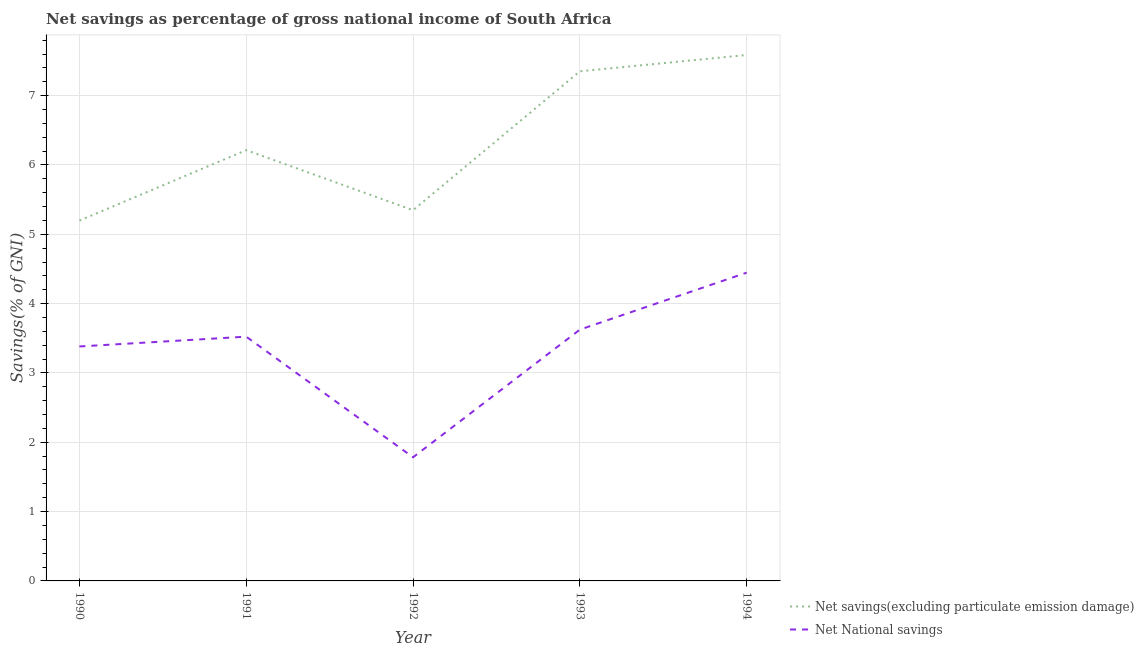Does the line corresponding to net savings(excluding particulate emission damage) intersect with the line corresponding to net national savings?
Give a very brief answer. No. What is the net national savings in 1993?
Offer a very short reply. 3.63. Across all years, what is the maximum net savings(excluding particulate emission damage)?
Ensure brevity in your answer.  7.59. Across all years, what is the minimum net savings(excluding particulate emission damage)?
Provide a short and direct response. 5.2. What is the total net savings(excluding particulate emission damage) in the graph?
Provide a succinct answer. 31.7. What is the difference between the net savings(excluding particulate emission damage) in 1993 and that in 1994?
Offer a terse response. -0.24. What is the difference between the net savings(excluding particulate emission damage) in 1991 and the net national savings in 1994?
Your answer should be compact. 1.77. What is the average net savings(excluding particulate emission damage) per year?
Provide a succinct answer. 6.34. In the year 1993, what is the difference between the net savings(excluding particulate emission damage) and net national savings?
Ensure brevity in your answer.  3.73. In how many years, is the net national savings greater than 2.6 %?
Provide a succinct answer. 4. What is the ratio of the net national savings in 1990 to that in 1994?
Make the answer very short. 0.76. What is the difference between the highest and the second highest net savings(excluding particulate emission damage)?
Keep it short and to the point. 0.24. What is the difference between the highest and the lowest net savings(excluding particulate emission damage)?
Ensure brevity in your answer.  2.39. Is the net savings(excluding particulate emission damage) strictly greater than the net national savings over the years?
Offer a very short reply. Yes. Is the net savings(excluding particulate emission damage) strictly less than the net national savings over the years?
Make the answer very short. No. How many years are there in the graph?
Offer a terse response. 5. What is the difference between two consecutive major ticks on the Y-axis?
Offer a terse response. 1. Are the values on the major ticks of Y-axis written in scientific E-notation?
Your answer should be very brief. No. Does the graph contain any zero values?
Your answer should be compact. No. How are the legend labels stacked?
Offer a very short reply. Vertical. What is the title of the graph?
Your answer should be compact. Net savings as percentage of gross national income of South Africa. Does "% of gross capital formation" appear as one of the legend labels in the graph?
Your answer should be very brief. No. What is the label or title of the X-axis?
Ensure brevity in your answer.  Year. What is the label or title of the Y-axis?
Provide a succinct answer. Savings(% of GNI). What is the Savings(% of GNI) in Net savings(excluding particulate emission damage) in 1990?
Offer a terse response. 5.2. What is the Savings(% of GNI) in Net National savings in 1990?
Offer a very short reply. 3.38. What is the Savings(% of GNI) of Net savings(excluding particulate emission damage) in 1991?
Give a very brief answer. 6.21. What is the Savings(% of GNI) in Net National savings in 1991?
Provide a short and direct response. 3.52. What is the Savings(% of GNI) of Net savings(excluding particulate emission damage) in 1992?
Ensure brevity in your answer.  5.35. What is the Savings(% of GNI) in Net National savings in 1992?
Give a very brief answer. 1.78. What is the Savings(% of GNI) of Net savings(excluding particulate emission damage) in 1993?
Your response must be concise. 7.35. What is the Savings(% of GNI) in Net National savings in 1993?
Offer a terse response. 3.63. What is the Savings(% of GNI) of Net savings(excluding particulate emission damage) in 1994?
Give a very brief answer. 7.59. What is the Savings(% of GNI) in Net National savings in 1994?
Your response must be concise. 4.45. Across all years, what is the maximum Savings(% of GNI) in Net savings(excluding particulate emission damage)?
Give a very brief answer. 7.59. Across all years, what is the maximum Savings(% of GNI) in Net National savings?
Your answer should be very brief. 4.45. Across all years, what is the minimum Savings(% of GNI) in Net savings(excluding particulate emission damage)?
Provide a succinct answer. 5.2. Across all years, what is the minimum Savings(% of GNI) of Net National savings?
Ensure brevity in your answer.  1.78. What is the total Savings(% of GNI) of Net savings(excluding particulate emission damage) in the graph?
Offer a very short reply. 31.7. What is the total Savings(% of GNI) of Net National savings in the graph?
Offer a terse response. 16.76. What is the difference between the Savings(% of GNI) in Net savings(excluding particulate emission damage) in 1990 and that in 1991?
Ensure brevity in your answer.  -1.02. What is the difference between the Savings(% of GNI) of Net National savings in 1990 and that in 1991?
Keep it short and to the point. -0.14. What is the difference between the Savings(% of GNI) of Net savings(excluding particulate emission damage) in 1990 and that in 1992?
Your answer should be compact. -0.15. What is the difference between the Savings(% of GNI) of Net National savings in 1990 and that in 1992?
Offer a terse response. 1.6. What is the difference between the Savings(% of GNI) of Net savings(excluding particulate emission damage) in 1990 and that in 1993?
Offer a terse response. -2.15. What is the difference between the Savings(% of GNI) of Net National savings in 1990 and that in 1993?
Keep it short and to the point. -0.24. What is the difference between the Savings(% of GNI) in Net savings(excluding particulate emission damage) in 1990 and that in 1994?
Provide a short and direct response. -2.39. What is the difference between the Savings(% of GNI) of Net National savings in 1990 and that in 1994?
Your answer should be very brief. -1.06. What is the difference between the Savings(% of GNI) of Net savings(excluding particulate emission damage) in 1991 and that in 1992?
Ensure brevity in your answer.  0.87. What is the difference between the Savings(% of GNI) in Net National savings in 1991 and that in 1992?
Your response must be concise. 1.74. What is the difference between the Savings(% of GNI) in Net savings(excluding particulate emission damage) in 1991 and that in 1993?
Keep it short and to the point. -1.14. What is the difference between the Savings(% of GNI) in Net National savings in 1991 and that in 1993?
Give a very brief answer. -0.1. What is the difference between the Savings(% of GNI) in Net savings(excluding particulate emission damage) in 1991 and that in 1994?
Offer a terse response. -1.37. What is the difference between the Savings(% of GNI) in Net National savings in 1991 and that in 1994?
Make the answer very short. -0.92. What is the difference between the Savings(% of GNI) of Net savings(excluding particulate emission damage) in 1992 and that in 1993?
Offer a terse response. -2. What is the difference between the Savings(% of GNI) in Net National savings in 1992 and that in 1993?
Give a very brief answer. -1.84. What is the difference between the Savings(% of GNI) of Net savings(excluding particulate emission damage) in 1992 and that in 1994?
Your answer should be compact. -2.24. What is the difference between the Savings(% of GNI) in Net National savings in 1992 and that in 1994?
Provide a short and direct response. -2.66. What is the difference between the Savings(% of GNI) of Net savings(excluding particulate emission damage) in 1993 and that in 1994?
Ensure brevity in your answer.  -0.24. What is the difference between the Savings(% of GNI) in Net National savings in 1993 and that in 1994?
Offer a very short reply. -0.82. What is the difference between the Savings(% of GNI) in Net savings(excluding particulate emission damage) in 1990 and the Savings(% of GNI) in Net National savings in 1991?
Make the answer very short. 1.67. What is the difference between the Savings(% of GNI) of Net savings(excluding particulate emission damage) in 1990 and the Savings(% of GNI) of Net National savings in 1992?
Ensure brevity in your answer.  3.41. What is the difference between the Savings(% of GNI) of Net savings(excluding particulate emission damage) in 1990 and the Savings(% of GNI) of Net National savings in 1993?
Keep it short and to the point. 1.57. What is the difference between the Savings(% of GNI) of Net savings(excluding particulate emission damage) in 1990 and the Savings(% of GNI) of Net National savings in 1994?
Your answer should be very brief. 0.75. What is the difference between the Savings(% of GNI) of Net savings(excluding particulate emission damage) in 1991 and the Savings(% of GNI) of Net National savings in 1992?
Your answer should be compact. 4.43. What is the difference between the Savings(% of GNI) in Net savings(excluding particulate emission damage) in 1991 and the Savings(% of GNI) in Net National savings in 1993?
Your response must be concise. 2.59. What is the difference between the Savings(% of GNI) of Net savings(excluding particulate emission damage) in 1991 and the Savings(% of GNI) of Net National savings in 1994?
Your response must be concise. 1.77. What is the difference between the Savings(% of GNI) in Net savings(excluding particulate emission damage) in 1992 and the Savings(% of GNI) in Net National savings in 1993?
Your response must be concise. 1.72. What is the difference between the Savings(% of GNI) of Net savings(excluding particulate emission damage) in 1992 and the Savings(% of GNI) of Net National savings in 1994?
Provide a short and direct response. 0.9. What is the difference between the Savings(% of GNI) in Net savings(excluding particulate emission damage) in 1993 and the Savings(% of GNI) in Net National savings in 1994?
Give a very brief answer. 2.9. What is the average Savings(% of GNI) in Net savings(excluding particulate emission damage) per year?
Offer a terse response. 6.34. What is the average Savings(% of GNI) of Net National savings per year?
Offer a very short reply. 3.35. In the year 1990, what is the difference between the Savings(% of GNI) in Net savings(excluding particulate emission damage) and Savings(% of GNI) in Net National savings?
Ensure brevity in your answer.  1.82. In the year 1991, what is the difference between the Savings(% of GNI) in Net savings(excluding particulate emission damage) and Savings(% of GNI) in Net National savings?
Give a very brief answer. 2.69. In the year 1992, what is the difference between the Savings(% of GNI) of Net savings(excluding particulate emission damage) and Savings(% of GNI) of Net National savings?
Provide a succinct answer. 3.56. In the year 1993, what is the difference between the Savings(% of GNI) of Net savings(excluding particulate emission damage) and Savings(% of GNI) of Net National savings?
Ensure brevity in your answer.  3.73. In the year 1994, what is the difference between the Savings(% of GNI) in Net savings(excluding particulate emission damage) and Savings(% of GNI) in Net National savings?
Offer a terse response. 3.14. What is the ratio of the Savings(% of GNI) of Net savings(excluding particulate emission damage) in 1990 to that in 1991?
Keep it short and to the point. 0.84. What is the ratio of the Savings(% of GNI) of Net National savings in 1990 to that in 1991?
Offer a very short reply. 0.96. What is the ratio of the Savings(% of GNI) of Net savings(excluding particulate emission damage) in 1990 to that in 1992?
Provide a succinct answer. 0.97. What is the ratio of the Savings(% of GNI) of Net National savings in 1990 to that in 1992?
Provide a short and direct response. 1.9. What is the ratio of the Savings(% of GNI) in Net savings(excluding particulate emission damage) in 1990 to that in 1993?
Offer a very short reply. 0.71. What is the ratio of the Savings(% of GNI) of Net National savings in 1990 to that in 1993?
Your answer should be compact. 0.93. What is the ratio of the Savings(% of GNI) of Net savings(excluding particulate emission damage) in 1990 to that in 1994?
Offer a terse response. 0.69. What is the ratio of the Savings(% of GNI) of Net National savings in 1990 to that in 1994?
Your answer should be very brief. 0.76. What is the ratio of the Savings(% of GNI) in Net savings(excluding particulate emission damage) in 1991 to that in 1992?
Provide a short and direct response. 1.16. What is the ratio of the Savings(% of GNI) of Net National savings in 1991 to that in 1992?
Keep it short and to the point. 1.98. What is the ratio of the Savings(% of GNI) in Net savings(excluding particulate emission damage) in 1991 to that in 1993?
Your answer should be compact. 0.85. What is the ratio of the Savings(% of GNI) of Net National savings in 1991 to that in 1993?
Offer a very short reply. 0.97. What is the ratio of the Savings(% of GNI) of Net savings(excluding particulate emission damage) in 1991 to that in 1994?
Ensure brevity in your answer.  0.82. What is the ratio of the Savings(% of GNI) of Net National savings in 1991 to that in 1994?
Your answer should be compact. 0.79. What is the ratio of the Savings(% of GNI) of Net savings(excluding particulate emission damage) in 1992 to that in 1993?
Keep it short and to the point. 0.73. What is the ratio of the Savings(% of GNI) in Net National savings in 1992 to that in 1993?
Provide a succinct answer. 0.49. What is the ratio of the Savings(% of GNI) in Net savings(excluding particulate emission damage) in 1992 to that in 1994?
Keep it short and to the point. 0.7. What is the ratio of the Savings(% of GNI) of Net National savings in 1992 to that in 1994?
Provide a short and direct response. 0.4. What is the ratio of the Savings(% of GNI) in Net National savings in 1993 to that in 1994?
Provide a short and direct response. 0.82. What is the difference between the highest and the second highest Savings(% of GNI) in Net savings(excluding particulate emission damage)?
Make the answer very short. 0.24. What is the difference between the highest and the second highest Savings(% of GNI) in Net National savings?
Keep it short and to the point. 0.82. What is the difference between the highest and the lowest Savings(% of GNI) of Net savings(excluding particulate emission damage)?
Make the answer very short. 2.39. What is the difference between the highest and the lowest Savings(% of GNI) in Net National savings?
Ensure brevity in your answer.  2.66. 